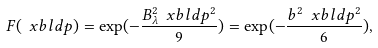<formula> <loc_0><loc_0><loc_500><loc_500>F ( \ x b l d { p } ) = \exp ( - \frac { B _ { \lambda } ^ { 2 } \ x b l d { p } ^ { 2 } } { 9 } ) = \exp ( - \frac { b ^ { 2 } \ x b l d { p } ^ { 2 } } { 6 } ) ,</formula> 